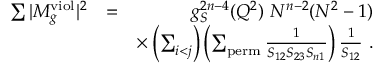Convert formula to latex. <formula><loc_0><loc_0><loc_500><loc_500>\begin{array} { r l r } { \sum | M _ { g } ^ { v i o l } | ^ { 2 } } & { = } & { g _ { S } ^ { 2 n - 4 } ( Q ^ { 2 } ) N ^ { n - 2 } ( N ^ { 2 } - 1 ) } \\ & { \times \left ( \sum _ { i < j } \right ) \left ( \sum _ { p e r m } \frac { 1 } { S _ { 1 2 } S _ { 2 3 } S _ { n 1 } } \right ) \frac { 1 } { S _ { 1 2 } } . } \end{array}</formula> 